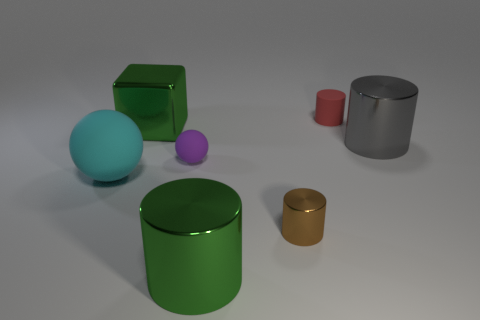There is another tiny object that is the same shape as the brown thing; what is its color?
Provide a short and direct response. Red. There is another purple thing that is the same shape as the large matte thing; what size is it?
Make the answer very short. Small. There is a object that is behind the large green object that is behind the large cyan object; what color is it?
Give a very brief answer. Red. Is there anything else that is the same shape as the red object?
Keep it short and to the point. Yes. Are there an equal number of green cylinders right of the tiny brown metallic thing and tiny things that are behind the cyan matte thing?
Provide a succinct answer. No. How many spheres are either green metallic things or big cyan things?
Provide a succinct answer. 1. How many other objects are there of the same material as the cyan thing?
Ensure brevity in your answer.  2. There is a tiny matte object in front of the red rubber thing; what shape is it?
Provide a short and direct response. Sphere. The large green thing behind the cyan object on the left side of the green shiny cylinder is made of what material?
Offer a terse response. Metal. Is the number of large green cylinders behind the brown object greater than the number of green shiny cylinders?
Provide a succinct answer. No. 